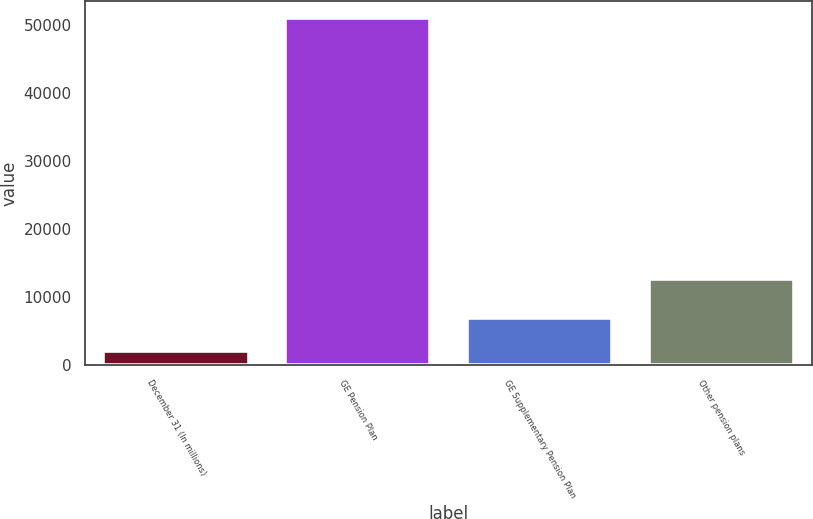Convert chart. <chart><loc_0><loc_0><loc_500><loc_500><bar_chart><fcel>December 31 (In millions)<fcel>GE Pension Plan<fcel>GE Supplementary Pension Plan<fcel>Other pension plans<nl><fcel>2013<fcel>50967<fcel>6908.4<fcel>12629<nl></chart> 